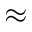Convert formula to latex. <formula><loc_0><loc_0><loc_500><loc_500>\approx</formula> 